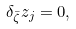Convert formula to latex. <formula><loc_0><loc_0><loc_500><loc_500>\delta _ { \bar { \zeta } } z _ { j } = 0 ,</formula> 